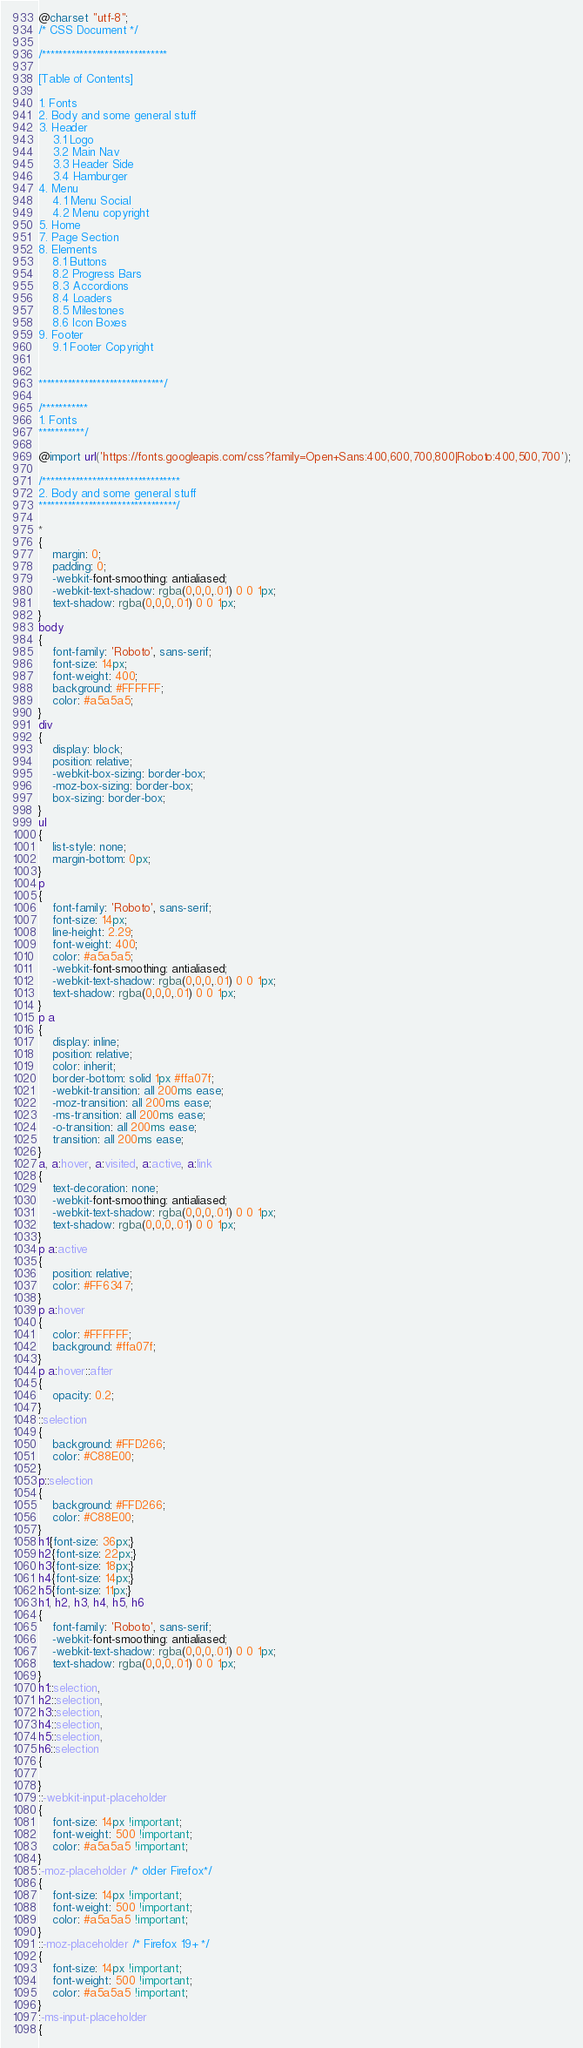Convert code to text. <code><loc_0><loc_0><loc_500><loc_500><_CSS_>@charset "utf-8";
/* CSS Document */

/******************************

[Table of Contents]

1. Fonts
2. Body and some general stuff
3. Header
	3.1 Logo
	3.2 Main Nav
	3.3 Header Side
	3.4 Hamburger
4. Menu
	4.1 Menu Social
	4.2 Menu copyright
5. Home
7. Page Section
8. Elements
	8.1 Buttons
	8.2 Progress Bars
	8.3 Accordions
	8.4 Loaders
	8.5 Milestones
	8.6 Icon Boxes
9. Footer
	9.1 Footer Copyright


******************************/

/***********
1. Fonts
***********/

@import url('https://fonts.googleapis.com/css?family=Open+Sans:400,600,700,800|Roboto:400,500,700');

/*********************************
2. Body and some general stuff
*********************************/

*
{
	margin: 0;
	padding: 0;
	-webkit-font-smoothing: antialiased;
	-webkit-text-shadow: rgba(0,0,0,.01) 0 0 1px;
	text-shadow: rgba(0,0,0,.01) 0 0 1px;
}
body
{
	font-family: 'Roboto', sans-serif;
	font-size: 14px;
	font-weight: 400;
	background: #FFFFFF;
	color: #a5a5a5;
}
div
{
	display: block;
	position: relative;
	-webkit-box-sizing: border-box;
    -moz-box-sizing: border-box;
    box-sizing: border-box;
}
ul
{
	list-style: none;
	margin-bottom: 0px;
}
p
{
	font-family: 'Roboto', sans-serif;
	font-size: 14px;
	line-height: 2.29;
	font-weight: 400;
	color: #a5a5a5;
	-webkit-font-smoothing: antialiased;
	-webkit-text-shadow: rgba(0,0,0,.01) 0 0 1px;
	text-shadow: rgba(0,0,0,.01) 0 0 1px;
}
p a
{
	display: inline;
	position: relative;
	color: inherit;
	border-bottom: solid 1px #ffa07f;
	-webkit-transition: all 200ms ease;
	-moz-transition: all 200ms ease;
	-ms-transition: all 200ms ease;
	-o-transition: all 200ms ease;
	transition: all 200ms ease;
}
a, a:hover, a:visited, a:active, a:link
{
	text-decoration: none;
	-webkit-font-smoothing: antialiased;
	-webkit-text-shadow: rgba(0,0,0,.01) 0 0 1px;
	text-shadow: rgba(0,0,0,.01) 0 0 1px;
}
p a:active
{
	position: relative;
	color: #FF6347;
}
p a:hover
{
	color: #FFFFFF;
	background: #ffa07f;
}
p a:hover::after
{
	opacity: 0.2;
}
::selection
{
	background: #FFD266;
	color: #C88E00;
}
p::selection
{
	background: #FFD266;
	color: #C88E00;
}
h1{font-size: 36px;}
h2{font-size: 22px;}
h3{font-size: 18px;}
h4{font-size: 14px;}
h5{font-size: 11px;}
h1, h2, h3, h4, h5, h6
{
	font-family: 'Roboto', sans-serif;
	-webkit-font-smoothing: antialiased;
	-webkit-text-shadow: rgba(0,0,0,.01) 0 0 1px;
	text-shadow: rgba(0,0,0,.01) 0 0 1px;
}
h1::selection, 
h2::selection, 
h3::selection, 
h4::selection, 
h5::selection, 
h6::selection
{
	
}
::-webkit-input-placeholder
{
	font-size: 14px !important;
	font-weight: 500 !important;
	color: #a5a5a5 !important;
}
:-moz-placeholder /* older Firefox*/
{
	font-size: 14px !important;
	font-weight: 500 !important;
	color: #a5a5a5 !important;
}
::-moz-placeholder /* Firefox 19+ */ 
{
	font-size: 14px !important;
	font-weight: 500 !important;
	color: #a5a5a5 !important;
} 
:-ms-input-placeholder
{ </code> 